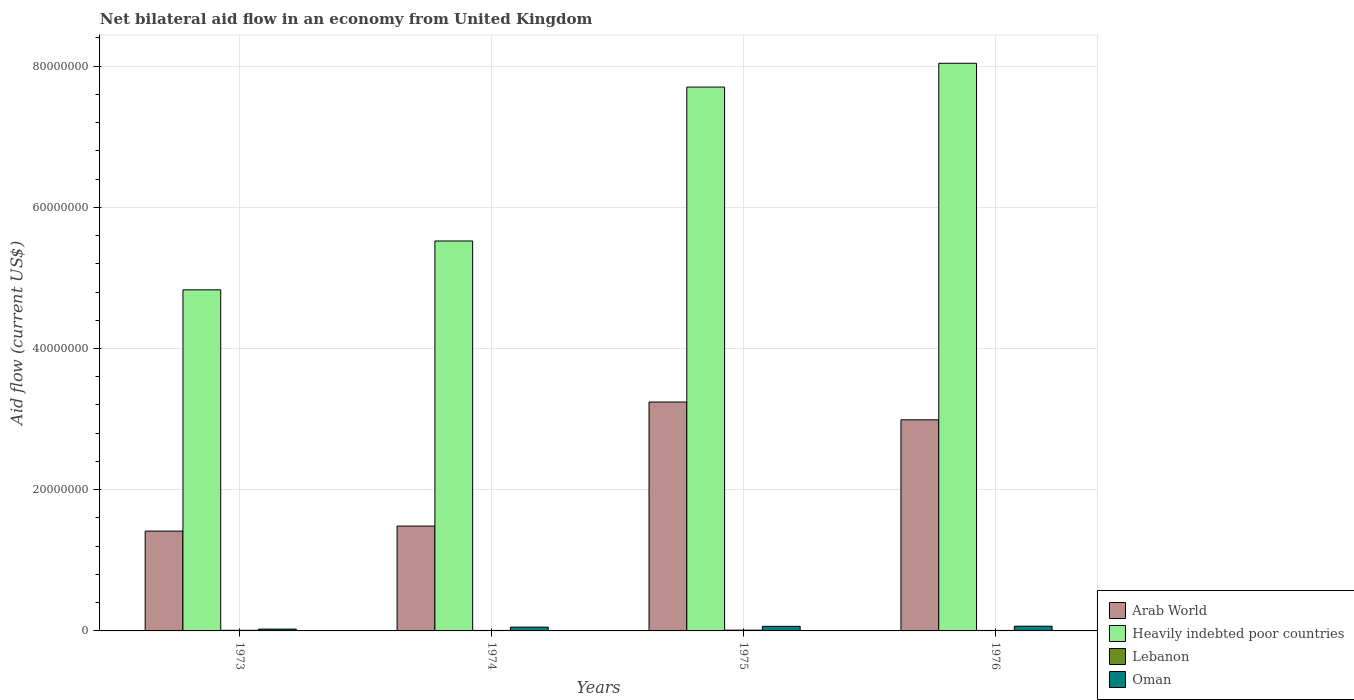Are the number of bars per tick equal to the number of legend labels?
Your answer should be very brief. Yes. How many bars are there on the 1st tick from the left?
Your answer should be compact. 4. How many bars are there on the 4th tick from the right?
Provide a succinct answer. 4. What is the label of the 3rd group of bars from the left?
Your response must be concise. 1975. What is the net bilateral aid flow in Oman in 1975?
Provide a succinct answer. 6.50e+05. Across all years, what is the maximum net bilateral aid flow in Oman?
Your answer should be very brief. 6.70e+05. Across all years, what is the minimum net bilateral aid flow in Heavily indebted poor countries?
Ensure brevity in your answer.  4.83e+07. In which year was the net bilateral aid flow in Lebanon maximum?
Provide a succinct answer. 1975. What is the total net bilateral aid flow in Lebanon in the graph?
Make the answer very short. 3.40e+05. What is the difference between the net bilateral aid flow in Lebanon in 1973 and the net bilateral aid flow in Arab World in 1974?
Your answer should be compact. -1.48e+07. What is the average net bilateral aid flow in Oman per year?
Keep it short and to the point. 5.30e+05. In the year 1976, what is the difference between the net bilateral aid flow in Oman and net bilateral aid flow in Arab World?
Your answer should be compact. -2.92e+07. What is the ratio of the net bilateral aid flow in Heavily indebted poor countries in 1974 to that in 1976?
Your answer should be compact. 0.69. Is the net bilateral aid flow in Lebanon in 1973 less than that in 1974?
Your answer should be compact. No. Is the difference between the net bilateral aid flow in Oman in 1974 and 1976 greater than the difference between the net bilateral aid flow in Arab World in 1974 and 1976?
Keep it short and to the point. Yes. What is the difference between the highest and the second highest net bilateral aid flow in Oman?
Keep it short and to the point. 2.00e+04. What is the difference between the highest and the lowest net bilateral aid flow in Heavily indebted poor countries?
Give a very brief answer. 3.21e+07. Is the sum of the net bilateral aid flow in Heavily indebted poor countries in 1973 and 1974 greater than the maximum net bilateral aid flow in Lebanon across all years?
Provide a succinct answer. Yes. What does the 2nd bar from the left in 1974 represents?
Your answer should be compact. Heavily indebted poor countries. What does the 1st bar from the right in 1973 represents?
Make the answer very short. Oman. Is it the case that in every year, the sum of the net bilateral aid flow in Oman and net bilateral aid flow in Heavily indebted poor countries is greater than the net bilateral aid flow in Arab World?
Make the answer very short. Yes. How many bars are there?
Offer a very short reply. 16. Are the values on the major ticks of Y-axis written in scientific E-notation?
Make the answer very short. No. Does the graph contain any zero values?
Keep it short and to the point. No. Where does the legend appear in the graph?
Provide a succinct answer. Bottom right. How many legend labels are there?
Make the answer very short. 4. How are the legend labels stacked?
Offer a very short reply. Vertical. What is the title of the graph?
Your answer should be compact. Net bilateral aid flow in an economy from United Kingdom. Does "Algeria" appear as one of the legend labels in the graph?
Ensure brevity in your answer.  No. What is the label or title of the Y-axis?
Give a very brief answer. Aid flow (current US$). What is the Aid flow (current US$) of Arab World in 1973?
Ensure brevity in your answer.  1.41e+07. What is the Aid flow (current US$) of Heavily indebted poor countries in 1973?
Your response must be concise. 4.83e+07. What is the Aid flow (current US$) of Oman in 1973?
Provide a succinct answer. 2.60e+05. What is the Aid flow (current US$) in Arab World in 1974?
Your answer should be very brief. 1.48e+07. What is the Aid flow (current US$) in Heavily indebted poor countries in 1974?
Give a very brief answer. 5.52e+07. What is the Aid flow (current US$) in Oman in 1974?
Give a very brief answer. 5.40e+05. What is the Aid flow (current US$) in Arab World in 1975?
Your answer should be compact. 3.24e+07. What is the Aid flow (current US$) in Heavily indebted poor countries in 1975?
Ensure brevity in your answer.  7.70e+07. What is the Aid flow (current US$) in Oman in 1975?
Keep it short and to the point. 6.50e+05. What is the Aid flow (current US$) in Arab World in 1976?
Your answer should be compact. 2.99e+07. What is the Aid flow (current US$) of Heavily indebted poor countries in 1976?
Give a very brief answer. 8.04e+07. What is the Aid flow (current US$) in Oman in 1976?
Provide a short and direct response. 6.70e+05. Across all years, what is the maximum Aid flow (current US$) in Arab World?
Your answer should be very brief. 3.24e+07. Across all years, what is the maximum Aid flow (current US$) of Heavily indebted poor countries?
Give a very brief answer. 8.04e+07. Across all years, what is the maximum Aid flow (current US$) in Oman?
Keep it short and to the point. 6.70e+05. Across all years, what is the minimum Aid flow (current US$) of Arab World?
Make the answer very short. 1.41e+07. Across all years, what is the minimum Aid flow (current US$) of Heavily indebted poor countries?
Offer a terse response. 4.83e+07. Across all years, what is the minimum Aid flow (current US$) in Lebanon?
Your answer should be compact. 7.00e+04. What is the total Aid flow (current US$) of Arab World in the graph?
Your answer should be compact. 9.13e+07. What is the total Aid flow (current US$) in Heavily indebted poor countries in the graph?
Make the answer very short. 2.61e+08. What is the total Aid flow (current US$) of Lebanon in the graph?
Give a very brief answer. 3.40e+05. What is the total Aid flow (current US$) in Oman in the graph?
Your answer should be very brief. 2.12e+06. What is the difference between the Aid flow (current US$) in Arab World in 1973 and that in 1974?
Offer a very short reply. -7.10e+05. What is the difference between the Aid flow (current US$) of Heavily indebted poor countries in 1973 and that in 1974?
Make the answer very short. -6.92e+06. What is the difference between the Aid flow (current US$) of Oman in 1973 and that in 1974?
Offer a terse response. -2.80e+05. What is the difference between the Aid flow (current US$) of Arab World in 1973 and that in 1975?
Give a very brief answer. -1.83e+07. What is the difference between the Aid flow (current US$) in Heavily indebted poor countries in 1973 and that in 1975?
Provide a succinct answer. -2.87e+07. What is the difference between the Aid flow (current US$) of Lebanon in 1973 and that in 1975?
Give a very brief answer. -2.00e+04. What is the difference between the Aid flow (current US$) in Oman in 1973 and that in 1975?
Your answer should be compact. -3.90e+05. What is the difference between the Aid flow (current US$) of Arab World in 1973 and that in 1976?
Give a very brief answer. -1.58e+07. What is the difference between the Aid flow (current US$) in Heavily indebted poor countries in 1973 and that in 1976?
Make the answer very short. -3.21e+07. What is the difference between the Aid flow (current US$) of Lebanon in 1973 and that in 1976?
Ensure brevity in your answer.  2.00e+04. What is the difference between the Aid flow (current US$) of Oman in 1973 and that in 1976?
Your answer should be compact. -4.10e+05. What is the difference between the Aid flow (current US$) in Arab World in 1974 and that in 1975?
Provide a short and direct response. -1.76e+07. What is the difference between the Aid flow (current US$) in Heavily indebted poor countries in 1974 and that in 1975?
Provide a succinct answer. -2.18e+07. What is the difference between the Aid flow (current US$) in Oman in 1974 and that in 1975?
Offer a terse response. -1.10e+05. What is the difference between the Aid flow (current US$) of Arab World in 1974 and that in 1976?
Ensure brevity in your answer.  -1.50e+07. What is the difference between the Aid flow (current US$) of Heavily indebted poor countries in 1974 and that in 1976?
Offer a terse response. -2.52e+07. What is the difference between the Aid flow (current US$) in Oman in 1974 and that in 1976?
Your answer should be very brief. -1.30e+05. What is the difference between the Aid flow (current US$) of Arab World in 1975 and that in 1976?
Offer a terse response. 2.52e+06. What is the difference between the Aid flow (current US$) of Heavily indebted poor countries in 1975 and that in 1976?
Keep it short and to the point. -3.37e+06. What is the difference between the Aid flow (current US$) of Lebanon in 1975 and that in 1976?
Your answer should be very brief. 4.00e+04. What is the difference between the Aid flow (current US$) of Oman in 1975 and that in 1976?
Keep it short and to the point. -2.00e+04. What is the difference between the Aid flow (current US$) of Arab World in 1973 and the Aid flow (current US$) of Heavily indebted poor countries in 1974?
Offer a very short reply. -4.11e+07. What is the difference between the Aid flow (current US$) of Arab World in 1973 and the Aid flow (current US$) of Lebanon in 1974?
Provide a short and direct response. 1.41e+07. What is the difference between the Aid flow (current US$) in Arab World in 1973 and the Aid flow (current US$) in Oman in 1974?
Keep it short and to the point. 1.36e+07. What is the difference between the Aid flow (current US$) in Heavily indebted poor countries in 1973 and the Aid flow (current US$) in Lebanon in 1974?
Provide a short and direct response. 4.82e+07. What is the difference between the Aid flow (current US$) of Heavily indebted poor countries in 1973 and the Aid flow (current US$) of Oman in 1974?
Keep it short and to the point. 4.78e+07. What is the difference between the Aid flow (current US$) of Lebanon in 1973 and the Aid flow (current US$) of Oman in 1974?
Your answer should be very brief. -4.50e+05. What is the difference between the Aid flow (current US$) in Arab World in 1973 and the Aid flow (current US$) in Heavily indebted poor countries in 1975?
Offer a terse response. -6.29e+07. What is the difference between the Aid flow (current US$) of Arab World in 1973 and the Aid flow (current US$) of Lebanon in 1975?
Your answer should be compact. 1.40e+07. What is the difference between the Aid flow (current US$) of Arab World in 1973 and the Aid flow (current US$) of Oman in 1975?
Offer a terse response. 1.35e+07. What is the difference between the Aid flow (current US$) of Heavily indebted poor countries in 1973 and the Aid flow (current US$) of Lebanon in 1975?
Provide a short and direct response. 4.82e+07. What is the difference between the Aid flow (current US$) in Heavily indebted poor countries in 1973 and the Aid flow (current US$) in Oman in 1975?
Your response must be concise. 4.77e+07. What is the difference between the Aid flow (current US$) of Lebanon in 1973 and the Aid flow (current US$) of Oman in 1975?
Your answer should be compact. -5.60e+05. What is the difference between the Aid flow (current US$) of Arab World in 1973 and the Aid flow (current US$) of Heavily indebted poor countries in 1976?
Give a very brief answer. -6.63e+07. What is the difference between the Aid flow (current US$) of Arab World in 1973 and the Aid flow (current US$) of Lebanon in 1976?
Your response must be concise. 1.41e+07. What is the difference between the Aid flow (current US$) of Arab World in 1973 and the Aid flow (current US$) of Oman in 1976?
Give a very brief answer. 1.35e+07. What is the difference between the Aid flow (current US$) in Heavily indebted poor countries in 1973 and the Aid flow (current US$) in Lebanon in 1976?
Give a very brief answer. 4.82e+07. What is the difference between the Aid flow (current US$) in Heavily indebted poor countries in 1973 and the Aid flow (current US$) in Oman in 1976?
Make the answer very short. 4.76e+07. What is the difference between the Aid flow (current US$) of Lebanon in 1973 and the Aid flow (current US$) of Oman in 1976?
Ensure brevity in your answer.  -5.80e+05. What is the difference between the Aid flow (current US$) of Arab World in 1974 and the Aid flow (current US$) of Heavily indebted poor countries in 1975?
Offer a very short reply. -6.22e+07. What is the difference between the Aid flow (current US$) of Arab World in 1974 and the Aid flow (current US$) of Lebanon in 1975?
Keep it short and to the point. 1.47e+07. What is the difference between the Aid flow (current US$) in Arab World in 1974 and the Aid flow (current US$) in Oman in 1975?
Your response must be concise. 1.42e+07. What is the difference between the Aid flow (current US$) in Heavily indebted poor countries in 1974 and the Aid flow (current US$) in Lebanon in 1975?
Your response must be concise. 5.51e+07. What is the difference between the Aid flow (current US$) of Heavily indebted poor countries in 1974 and the Aid flow (current US$) of Oman in 1975?
Your response must be concise. 5.46e+07. What is the difference between the Aid flow (current US$) in Lebanon in 1974 and the Aid flow (current US$) in Oman in 1975?
Offer a terse response. -5.80e+05. What is the difference between the Aid flow (current US$) of Arab World in 1974 and the Aid flow (current US$) of Heavily indebted poor countries in 1976?
Your response must be concise. -6.56e+07. What is the difference between the Aid flow (current US$) of Arab World in 1974 and the Aid flow (current US$) of Lebanon in 1976?
Ensure brevity in your answer.  1.48e+07. What is the difference between the Aid flow (current US$) of Arab World in 1974 and the Aid flow (current US$) of Oman in 1976?
Provide a succinct answer. 1.42e+07. What is the difference between the Aid flow (current US$) of Heavily indebted poor countries in 1974 and the Aid flow (current US$) of Lebanon in 1976?
Your response must be concise. 5.52e+07. What is the difference between the Aid flow (current US$) of Heavily indebted poor countries in 1974 and the Aid flow (current US$) of Oman in 1976?
Provide a short and direct response. 5.46e+07. What is the difference between the Aid flow (current US$) in Lebanon in 1974 and the Aid flow (current US$) in Oman in 1976?
Give a very brief answer. -6.00e+05. What is the difference between the Aid flow (current US$) in Arab World in 1975 and the Aid flow (current US$) in Heavily indebted poor countries in 1976?
Your answer should be compact. -4.80e+07. What is the difference between the Aid flow (current US$) in Arab World in 1975 and the Aid flow (current US$) in Lebanon in 1976?
Offer a very short reply. 3.24e+07. What is the difference between the Aid flow (current US$) in Arab World in 1975 and the Aid flow (current US$) in Oman in 1976?
Ensure brevity in your answer.  3.18e+07. What is the difference between the Aid flow (current US$) in Heavily indebted poor countries in 1975 and the Aid flow (current US$) in Lebanon in 1976?
Ensure brevity in your answer.  7.70e+07. What is the difference between the Aid flow (current US$) in Heavily indebted poor countries in 1975 and the Aid flow (current US$) in Oman in 1976?
Offer a terse response. 7.64e+07. What is the difference between the Aid flow (current US$) in Lebanon in 1975 and the Aid flow (current US$) in Oman in 1976?
Provide a succinct answer. -5.60e+05. What is the average Aid flow (current US$) in Arab World per year?
Ensure brevity in your answer.  2.28e+07. What is the average Aid flow (current US$) in Heavily indebted poor countries per year?
Offer a very short reply. 6.52e+07. What is the average Aid flow (current US$) of Lebanon per year?
Make the answer very short. 8.50e+04. What is the average Aid flow (current US$) in Oman per year?
Make the answer very short. 5.30e+05. In the year 1973, what is the difference between the Aid flow (current US$) in Arab World and Aid flow (current US$) in Heavily indebted poor countries?
Your answer should be very brief. -3.42e+07. In the year 1973, what is the difference between the Aid flow (current US$) of Arab World and Aid flow (current US$) of Lebanon?
Your response must be concise. 1.40e+07. In the year 1973, what is the difference between the Aid flow (current US$) in Arab World and Aid flow (current US$) in Oman?
Your response must be concise. 1.39e+07. In the year 1973, what is the difference between the Aid flow (current US$) in Heavily indebted poor countries and Aid flow (current US$) in Lebanon?
Your response must be concise. 4.82e+07. In the year 1973, what is the difference between the Aid flow (current US$) of Heavily indebted poor countries and Aid flow (current US$) of Oman?
Offer a very short reply. 4.80e+07. In the year 1974, what is the difference between the Aid flow (current US$) in Arab World and Aid flow (current US$) in Heavily indebted poor countries?
Ensure brevity in your answer.  -4.04e+07. In the year 1974, what is the difference between the Aid flow (current US$) of Arab World and Aid flow (current US$) of Lebanon?
Your response must be concise. 1.48e+07. In the year 1974, what is the difference between the Aid flow (current US$) in Arab World and Aid flow (current US$) in Oman?
Offer a terse response. 1.43e+07. In the year 1974, what is the difference between the Aid flow (current US$) in Heavily indebted poor countries and Aid flow (current US$) in Lebanon?
Ensure brevity in your answer.  5.52e+07. In the year 1974, what is the difference between the Aid flow (current US$) in Heavily indebted poor countries and Aid flow (current US$) in Oman?
Your response must be concise. 5.47e+07. In the year 1974, what is the difference between the Aid flow (current US$) of Lebanon and Aid flow (current US$) of Oman?
Offer a very short reply. -4.70e+05. In the year 1975, what is the difference between the Aid flow (current US$) of Arab World and Aid flow (current US$) of Heavily indebted poor countries?
Provide a short and direct response. -4.46e+07. In the year 1975, what is the difference between the Aid flow (current US$) of Arab World and Aid flow (current US$) of Lebanon?
Your response must be concise. 3.23e+07. In the year 1975, what is the difference between the Aid flow (current US$) of Arab World and Aid flow (current US$) of Oman?
Give a very brief answer. 3.18e+07. In the year 1975, what is the difference between the Aid flow (current US$) in Heavily indebted poor countries and Aid flow (current US$) in Lebanon?
Make the answer very short. 7.69e+07. In the year 1975, what is the difference between the Aid flow (current US$) of Heavily indebted poor countries and Aid flow (current US$) of Oman?
Provide a short and direct response. 7.64e+07. In the year 1975, what is the difference between the Aid flow (current US$) in Lebanon and Aid flow (current US$) in Oman?
Ensure brevity in your answer.  -5.40e+05. In the year 1976, what is the difference between the Aid flow (current US$) of Arab World and Aid flow (current US$) of Heavily indebted poor countries?
Provide a succinct answer. -5.05e+07. In the year 1976, what is the difference between the Aid flow (current US$) in Arab World and Aid flow (current US$) in Lebanon?
Provide a short and direct response. 2.98e+07. In the year 1976, what is the difference between the Aid flow (current US$) in Arab World and Aid flow (current US$) in Oman?
Ensure brevity in your answer.  2.92e+07. In the year 1976, what is the difference between the Aid flow (current US$) of Heavily indebted poor countries and Aid flow (current US$) of Lebanon?
Your answer should be compact. 8.03e+07. In the year 1976, what is the difference between the Aid flow (current US$) of Heavily indebted poor countries and Aid flow (current US$) of Oman?
Make the answer very short. 7.97e+07. In the year 1976, what is the difference between the Aid flow (current US$) of Lebanon and Aid flow (current US$) of Oman?
Provide a succinct answer. -6.00e+05. What is the ratio of the Aid flow (current US$) in Arab World in 1973 to that in 1974?
Make the answer very short. 0.95. What is the ratio of the Aid flow (current US$) of Heavily indebted poor countries in 1973 to that in 1974?
Your answer should be compact. 0.87. What is the ratio of the Aid flow (current US$) in Oman in 1973 to that in 1974?
Provide a short and direct response. 0.48. What is the ratio of the Aid flow (current US$) of Arab World in 1973 to that in 1975?
Keep it short and to the point. 0.44. What is the ratio of the Aid flow (current US$) in Heavily indebted poor countries in 1973 to that in 1975?
Your response must be concise. 0.63. What is the ratio of the Aid flow (current US$) of Lebanon in 1973 to that in 1975?
Offer a very short reply. 0.82. What is the ratio of the Aid flow (current US$) of Arab World in 1973 to that in 1976?
Offer a very short reply. 0.47. What is the ratio of the Aid flow (current US$) of Heavily indebted poor countries in 1973 to that in 1976?
Make the answer very short. 0.6. What is the ratio of the Aid flow (current US$) of Lebanon in 1973 to that in 1976?
Your response must be concise. 1.29. What is the ratio of the Aid flow (current US$) in Oman in 1973 to that in 1976?
Give a very brief answer. 0.39. What is the ratio of the Aid flow (current US$) in Arab World in 1974 to that in 1975?
Your answer should be very brief. 0.46. What is the ratio of the Aid flow (current US$) of Heavily indebted poor countries in 1974 to that in 1975?
Offer a very short reply. 0.72. What is the ratio of the Aid flow (current US$) of Lebanon in 1974 to that in 1975?
Keep it short and to the point. 0.64. What is the ratio of the Aid flow (current US$) in Oman in 1974 to that in 1975?
Provide a succinct answer. 0.83. What is the ratio of the Aid flow (current US$) of Arab World in 1974 to that in 1976?
Your response must be concise. 0.5. What is the ratio of the Aid flow (current US$) in Heavily indebted poor countries in 1974 to that in 1976?
Give a very brief answer. 0.69. What is the ratio of the Aid flow (current US$) in Oman in 1974 to that in 1976?
Your answer should be very brief. 0.81. What is the ratio of the Aid flow (current US$) in Arab World in 1975 to that in 1976?
Give a very brief answer. 1.08. What is the ratio of the Aid flow (current US$) of Heavily indebted poor countries in 1975 to that in 1976?
Offer a terse response. 0.96. What is the ratio of the Aid flow (current US$) of Lebanon in 1975 to that in 1976?
Make the answer very short. 1.57. What is the ratio of the Aid flow (current US$) in Oman in 1975 to that in 1976?
Provide a short and direct response. 0.97. What is the difference between the highest and the second highest Aid flow (current US$) in Arab World?
Offer a terse response. 2.52e+06. What is the difference between the highest and the second highest Aid flow (current US$) of Heavily indebted poor countries?
Make the answer very short. 3.37e+06. What is the difference between the highest and the second highest Aid flow (current US$) of Oman?
Provide a succinct answer. 2.00e+04. What is the difference between the highest and the lowest Aid flow (current US$) in Arab World?
Give a very brief answer. 1.83e+07. What is the difference between the highest and the lowest Aid flow (current US$) in Heavily indebted poor countries?
Offer a very short reply. 3.21e+07. What is the difference between the highest and the lowest Aid flow (current US$) in Lebanon?
Your answer should be compact. 4.00e+04. What is the difference between the highest and the lowest Aid flow (current US$) of Oman?
Your answer should be very brief. 4.10e+05. 